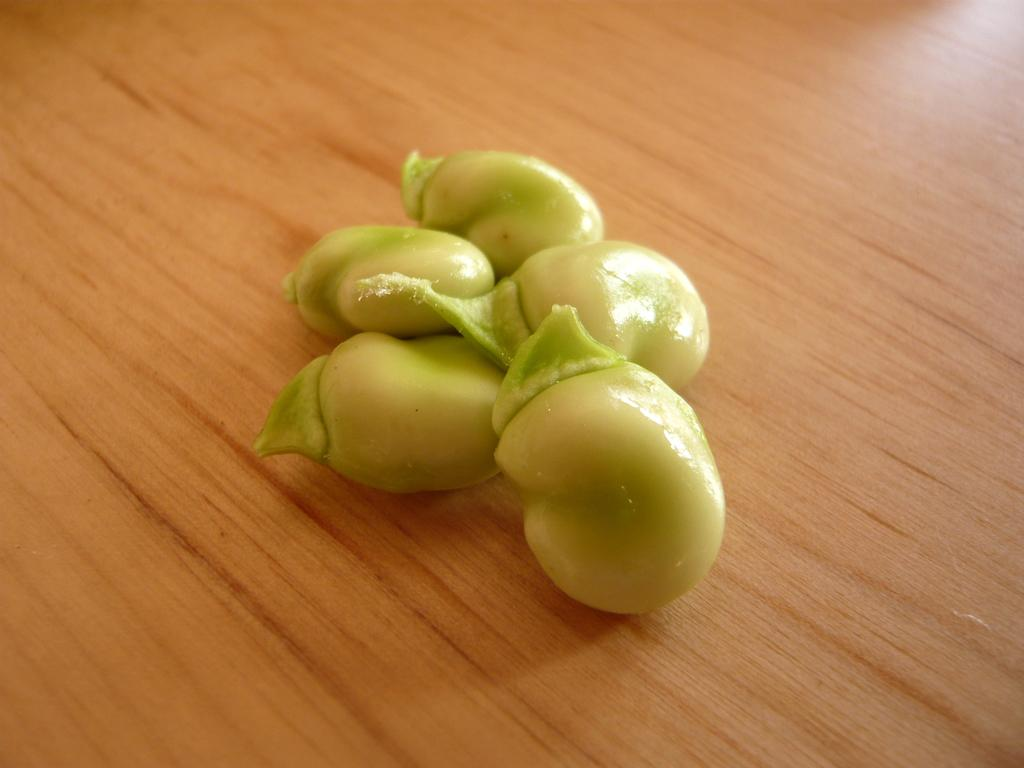What type of beans are visible in the image? There are broad beans in the image. What is the color of the broad beans? The broad beans are light green in color. On what surface are the broad beans placed? The broad beans are placed on a wooden table. What type of fireman is standing next to the broad beans in the image? There is no fireman present in the image; it only features broad beans on a wooden table. 